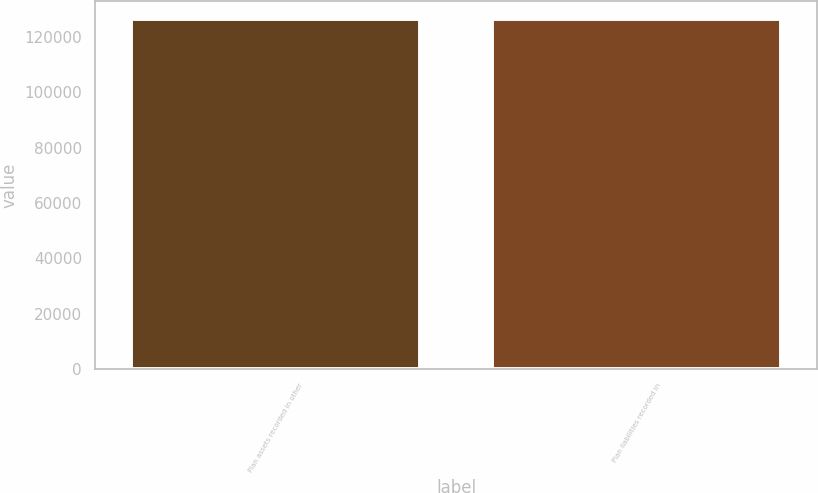Convert chart to OTSL. <chart><loc_0><loc_0><loc_500><loc_500><bar_chart><fcel>Plan assets recorded in other<fcel>Plan liabilities recorded in<nl><fcel>126621<fcel>126621<nl></chart> 